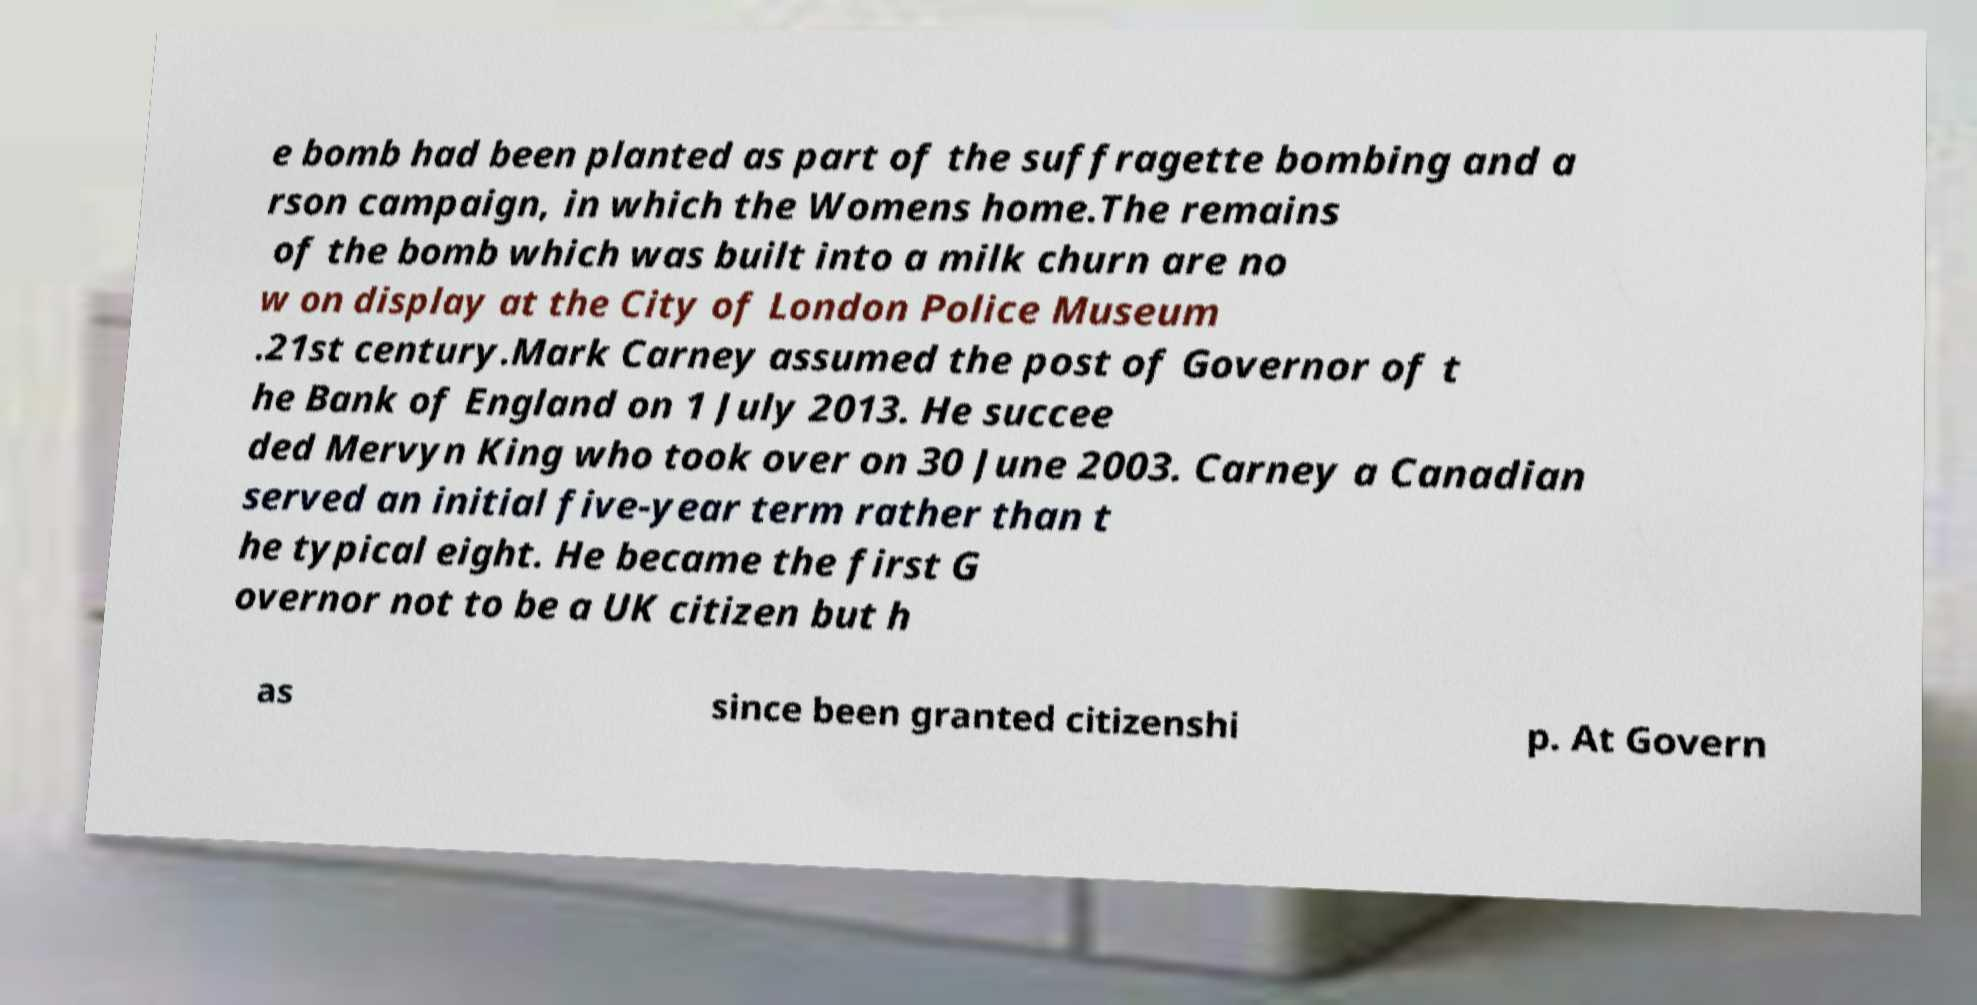There's text embedded in this image that I need extracted. Can you transcribe it verbatim? e bomb had been planted as part of the suffragette bombing and a rson campaign, in which the Womens home.The remains of the bomb which was built into a milk churn are no w on display at the City of London Police Museum .21st century.Mark Carney assumed the post of Governor of t he Bank of England on 1 July 2013. He succee ded Mervyn King who took over on 30 June 2003. Carney a Canadian served an initial five-year term rather than t he typical eight. He became the first G overnor not to be a UK citizen but h as since been granted citizenshi p. At Govern 